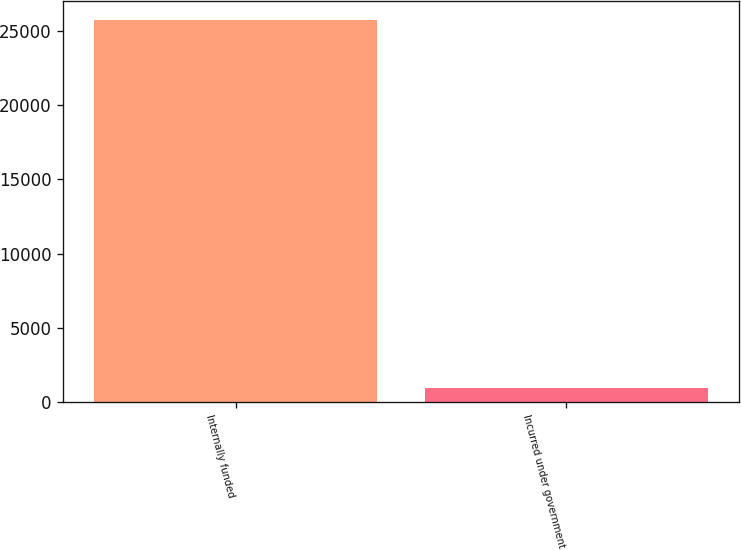Convert chart. <chart><loc_0><loc_0><loc_500><loc_500><bar_chart><fcel>Internally funded<fcel>Incurred under government<nl><fcel>25735<fcel>942<nl></chart> 